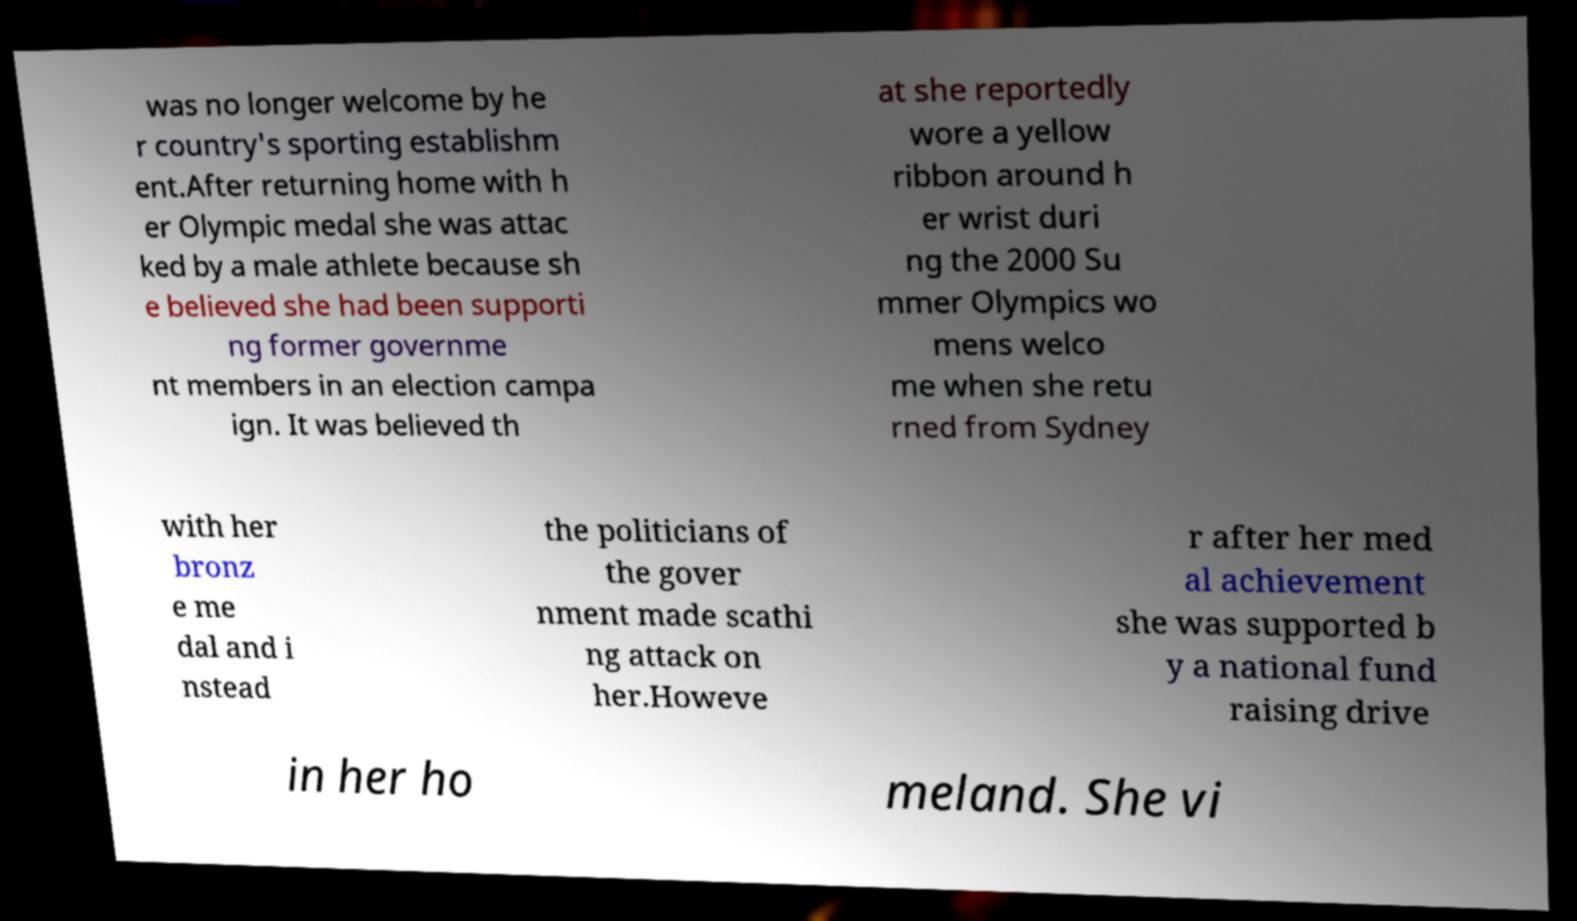Please identify and transcribe the text found in this image. was no longer welcome by he r country's sporting establishm ent.After returning home with h er Olympic medal she was attac ked by a male athlete because sh e believed she had been supporti ng former governme nt members in an election campa ign. It was believed th at she reportedly wore a yellow ribbon around h er wrist duri ng the 2000 Su mmer Olympics wo mens welco me when she retu rned from Sydney with her bronz e me dal and i nstead the politicians of the gover nment made scathi ng attack on her.Howeve r after her med al achievement she was supported b y a national fund raising drive in her ho meland. She vi 